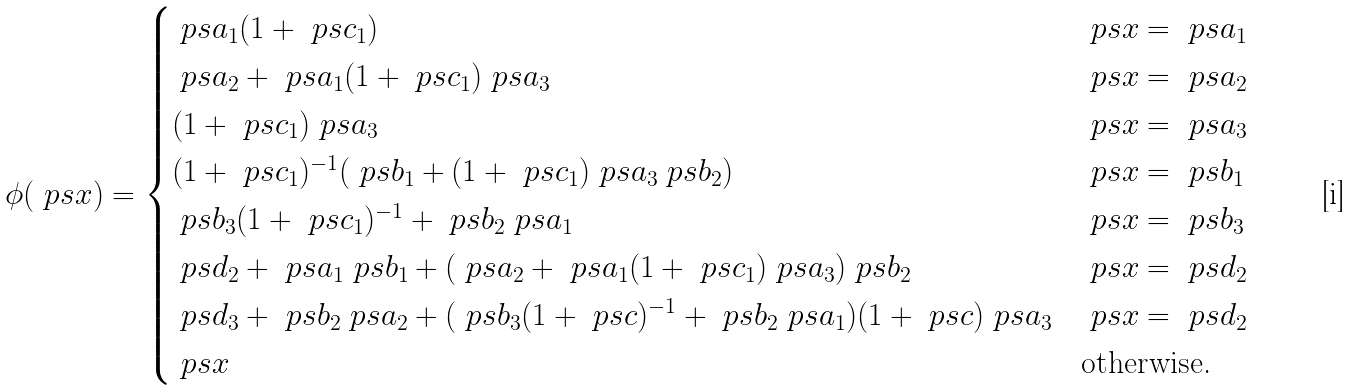Convert formula to latex. <formula><loc_0><loc_0><loc_500><loc_500>\phi ( \ p s { x } ) = \begin{cases} \ p s { a } _ { 1 } ( 1 + \ p s { c } _ { 1 } ) & \ p s { x } = \ p s { a } _ { 1 } \\ \ p s { a } _ { 2 } + \ p s { a } _ { 1 } ( 1 + \ p s { c } _ { 1 } ) \ p s { a } _ { 3 } & \ p s { x } = \ p s { a } _ { 2 } \\ ( 1 + \ p s { c } _ { 1 } ) \ p s { a } _ { 3 } & \ p s { x } = \ p s { a } _ { 3 } \\ ( 1 + \ p s { c } _ { 1 } ) ^ { - 1 } ( \ p s { b } _ { 1 } + ( 1 + \ p s { c } _ { 1 } ) \ p s { a } _ { 3 } \ p s { b } _ { 2 } ) & \ p s { x } = \ p s { b } _ { 1 } \\ \ p s { b } _ { 3 } ( 1 + \ p s { c } _ { 1 } ) ^ { - 1 } + \ p s { b } _ { 2 } \ p s { a } _ { 1 } & \ p s { x } = \ p s { b } _ { 3 } \\ \ p s { d } _ { 2 } + \ p s { a } _ { 1 } \ p s { b } _ { 1 } + ( \ p s { a } _ { 2 } + \ p s { a } _ { 1 } ( 1 + \ p s { c } _ { 1 } ) \ p s { a } _ { 3 } ) \ p s { b } _ { 2 } & \ p s { x } = \ p s { d } _ { 2 } \\ \ p s { d } _ { 3 } + \ p s { b } _ { 2 } \ p s { a } _ { 2 } + ( \ p s { b } _ { 3 } ( 1 + \ p s { c } ) ^ { - 1 } + \ p s { b } _ { 2 } \ p s { a } _ { 1 } ) ( 1 + \ p s { c } ) \ p s { a } _ { 3 } & \ p s { x } = \ p s { d } _ { 2 } \\ \ p s { x } & \text {otherwise.} \end{cases}</formula> 